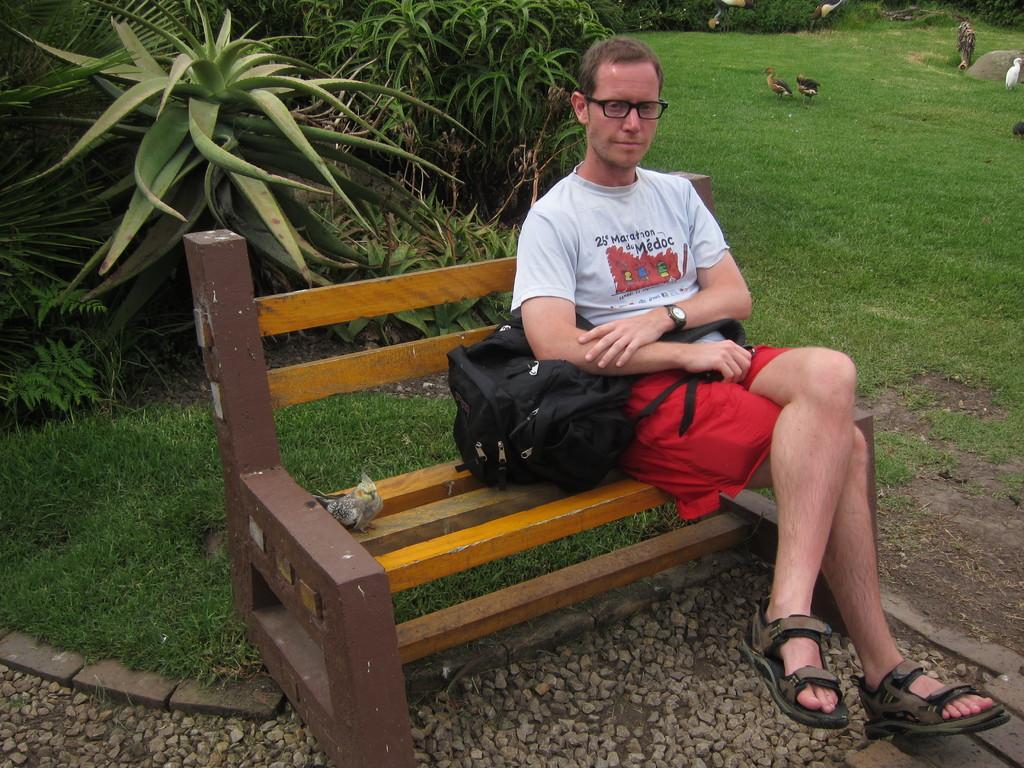In one or two sentences, can you explain what this image depicts? There is a man sitting on a park bench holding a backpack behind there are few birds walking on the grass and there are some garden plants at his back. 